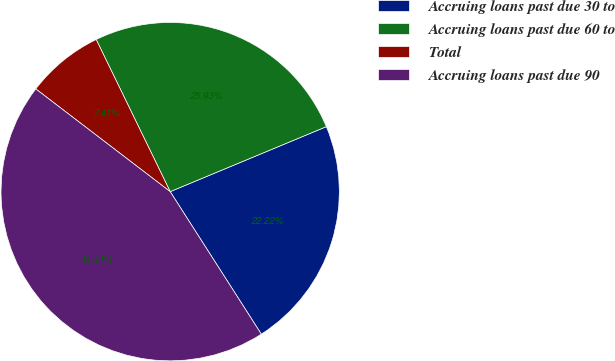<chart> <loc_0><loc_0><loc_500><loc_500><pie_chart><fcel>Accruing loans past due 30 to<fcel>Accruing loans past due 60 to<fcel>Total<fcel>Accruing loans past due 90<nl><fcel>22.22%<fcel>25.93%<fcel>7.41%<fcel>44.44%<nl></chart> 